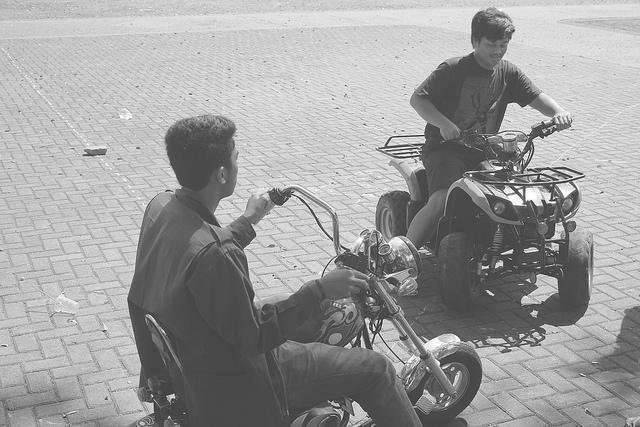Where are these men riding?
From the following set of four choices, select the accurate answer to respond to the question.
Options: Mountain, beach, woods, street. Street. 